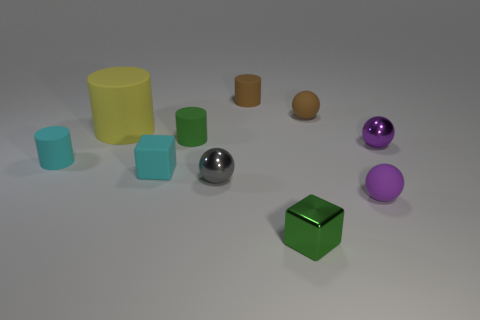Is there anything else that is the same size as the yellow cylinder?
Ensure brevity in your answer.  No. How many blue objects are either small metal objects or tiny balls?
Provide a short and direct response. 0. There is a small metallic sphere that is behind the tiny cylinder that is in front of the green rubber object; what color is it?
Give a very brief answer. Purple. There is a small thing that is the same color as the matte cube; what material is it?
Keep it short and to the point. Rubber. There is a tiny matte ball that is behind the tiny cyan cylinder; what color is it?
Offer a very short reply. Brown. Is the size of the green thing that is in front of the purple shiny sphere the same as the tiny brown matte sphere?
Your answer should be compact. Yes. What is the size of the object that is the same color as the metal block?
Your response must be concise. Small. Is there a cube that has the same size as the purple matte object?
Provide a succinct answer. Yes. Do the cube left of the small gray shiny object and the small rubber ball behind the large object have the same color?
Offer a very short reply. No. Are there any other matte cylinders of the same color as the large rubber cylinder?
Offer a very short reply. No. 